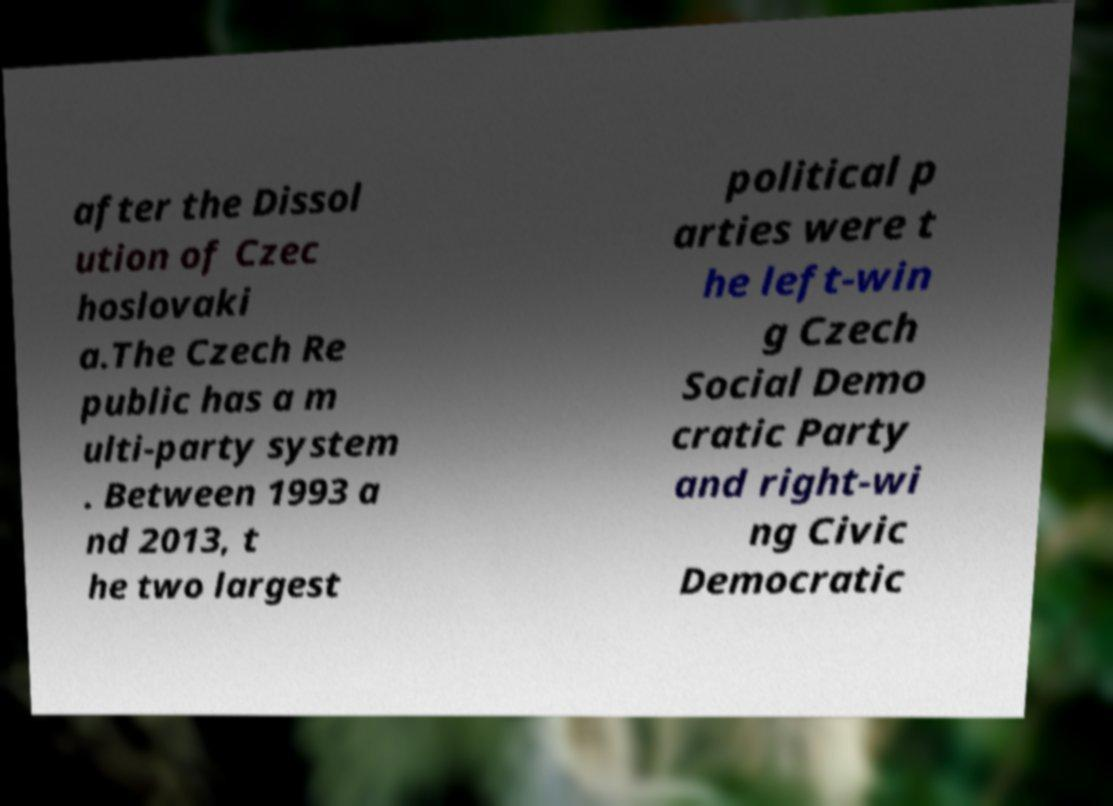Could you extract and type out the text from this image? after the Dissol ution of Czec hoslovaki a.The Czech Re public has a m ulti-party system . Between 1993 a nd 2013, t he two largest political p arties were t he left-win g Czech Social Demo cratic Party and right-wi ng Civic Democratic 